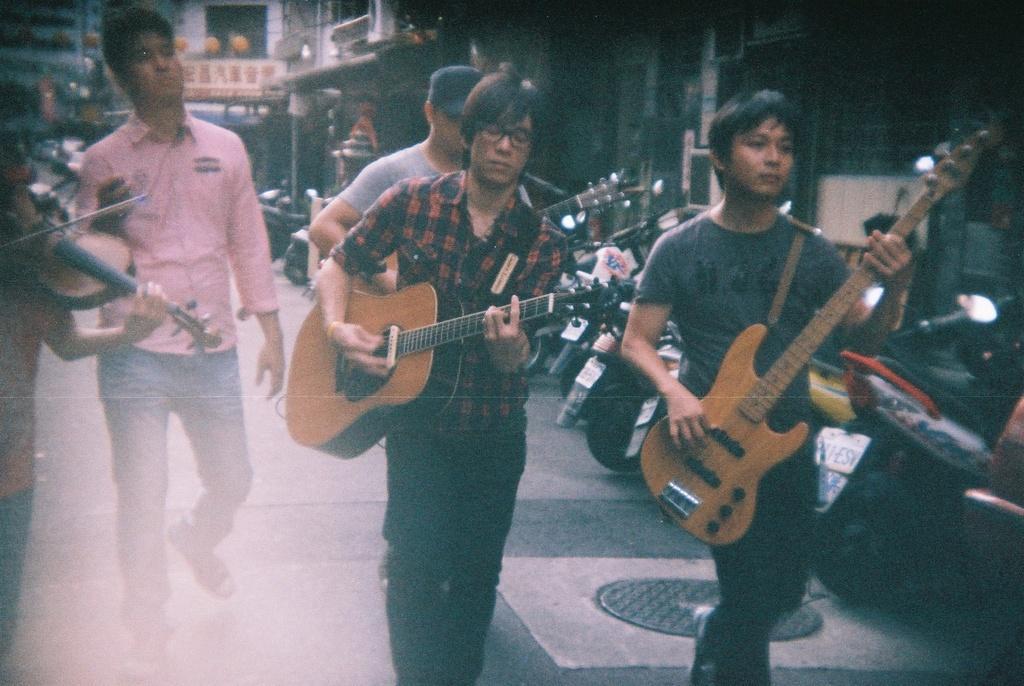How would you summarize this image in a sentence or two? There are three people are walking, holding and playing guitars. Beside them, there is a person in pink color dress walking. On the left hand, there is a person walking, holding and playing a violin. In the background, there is a hoarding, buildings, bikes, and some other items. 